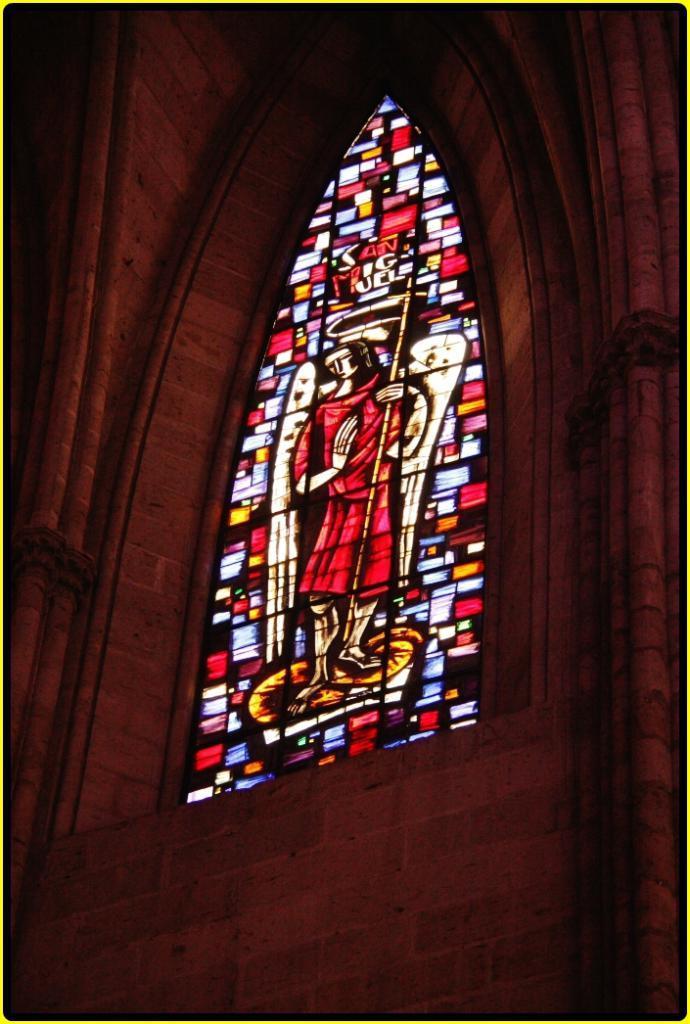Describe this image in one or two sentences. In this image there is a wall, there is a stained glass. 